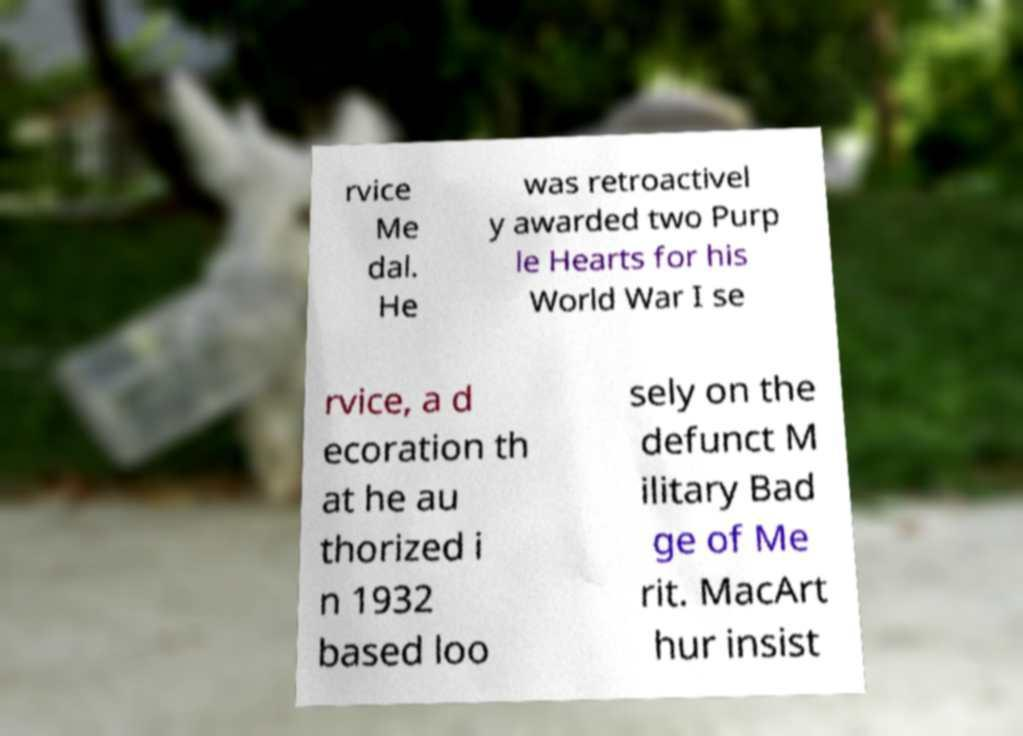Can you accurately transcribe the text from the provided image for me? rvice Me dal. He was retroactivel y awarded two Purp le Hearts for his World War I se rvice, a d ecoration th at he au thorized i n 1932 based loo sely on the defunct M ilitary Bad ge of Me rit. MacArt hur insist 